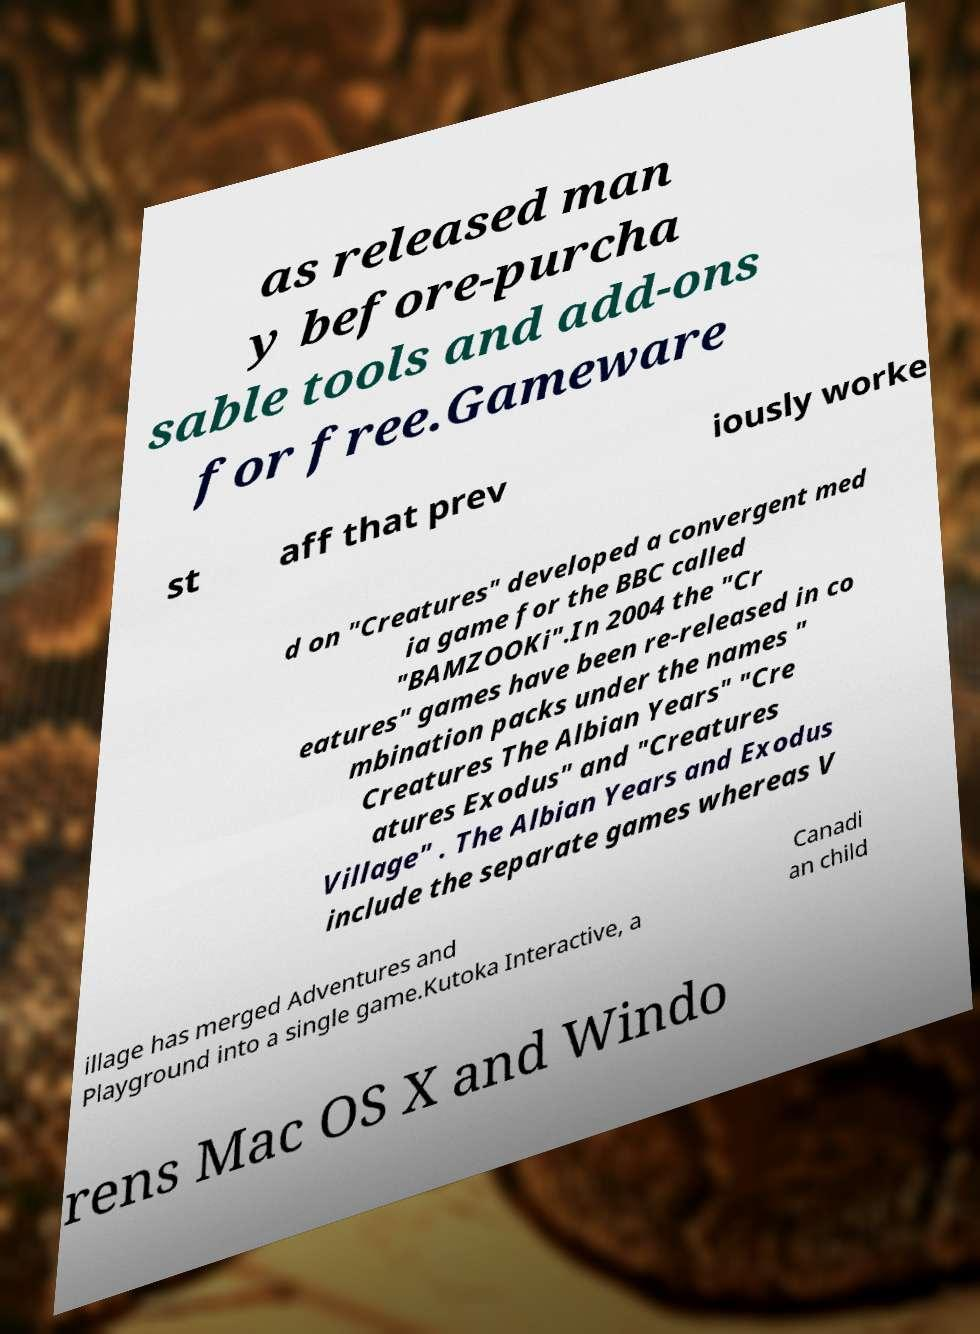Can you read and provide the text displayed in the image?This photo seems to have some interesting text. Can you extract and type it out for me? as released man y before-purcha sable tools and add-ons for free.Gameware st aff that prev iously worke d on "Creatures" developed a convergent med ia game for the BBC called "BAMZOOKi".In 2004 the "Cr eatures" games have been re-released in co mbination packs under the names " Creatures The Albian Years" "Cre atures Exodus" and "Creatures Village" . The Albian Years and Exodus include the separate games whereas V illage has merged Adventures and Playground into a single game.Kutoka Interactive, a Canadi an child rens Mac OS X and Windo 